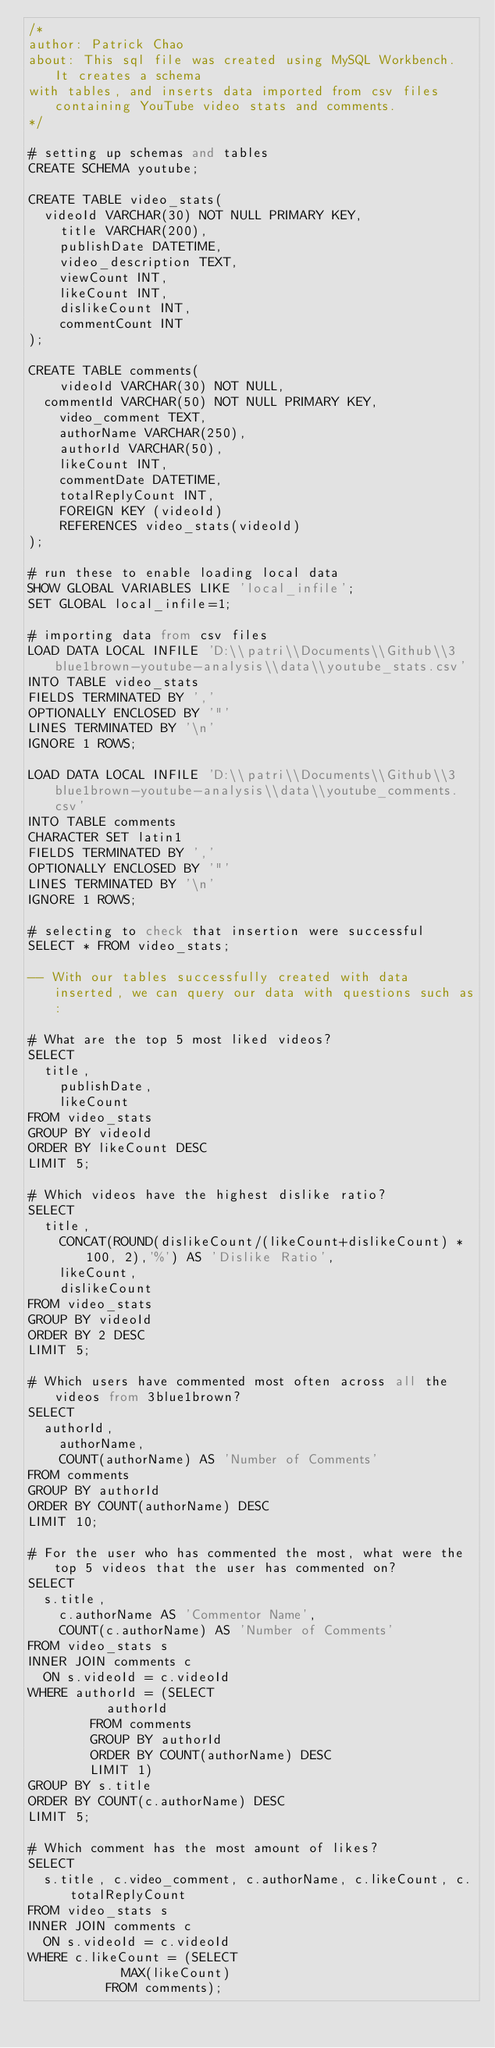Convert code to text. <code><loc_0><loc_0><loc_500><loc_500><_SQL_>/*
author: Patrick Chao
about: This sql file was created using MySQL Workbench. It creates a schema
with tables, and inserts data imported from csv files containing YouTube video stats and comments.
*/

# setting up schemas and tables
CREATE SCHEMA youtube;

CREATE TABLE video_stats(
	videoId VARCHAR(30) NOT NULL PRIMARY KEY,
    title VARCHAR(200),
    publishDate DATETIME,
    video_description TEXT,
    viewCount INT,
    likeCount INT,
    dislikeCount INT,
    commentCount INT
);
    
CREATE TABLE comments(
    videoId VARCHAR(30) NOT NULL,
	commentId VARCHAR(50) NOT NULL PRIMARY KEY,
    video_comment TEXT,
    authorName VARCHAR(250),
    authorId VARCHAR(50),
    likeCount INT,
    commentDate DATETIME,
    totalReplyCount INT,
    FOREIGN KEY (videoId)
		REFERENCES video_stats(videoId)
);
    
# run these to enable loading local data
SHOW GLOBAL VARIABLES LIKE 'local_infile';
SET GLOBAL local_infile=1;
    
# importing data from csv files
LOAD DATA LOCAL INFILE 'D:\\patri\\Documents\\Github\\3blue1brown-youtube-analysis\\data\\youtube_stats.csv'
INTO TABLE video_stats
FIELDS TERMINATED BY ','
OPTIONALLY ENCLOSED BY '"' 
LINES TERMINATED BY '\n'
IGNORE 1 ROWS;

LOAD DATA LOCAL INFILE 'D:\\patri\\Documents\\Github\\3blue1brown-youtube-analysis\\data\\youtube_comments.csv'
INTO TABLE comments
CHARACTER SET latin1
FIELDS TERMINATED BY ','
OPTIONALLY ENCLOSED BY '"' 
LINES TERMINATED BY '\n'
IGNORE 1 ROWS;

# selecting to check that insertion were successful
SELECT * FROM video_stats;

-- With our tables successfully created with data inserted, we can query our data with questions such as:

# What are the top 5 most liked videos?
SELECT
	title,
    publishDate, 
    likeCount
FROM video_stats
GROUP BY videoId
ORDER BY likeCount DESC
LIMIT 5;

# Which videos have the highest dislike ratio?
SELECT
	title, 
    CONCAT(ROUND(dislikeCount/(likeCount+dislikeCount) * 100, 2),'%') AS 'Dislike Ratio',
    likeCount, 
    dislikeCount
FROM video_stats
GROUP BY videoId
ORDER BY 2 DESC
LIMIT 5;

# Which users have commented most often across all the videos from 3blue1brown?
SELECT
	authorId, 
    authorName, 
    COUNT(authorName) AS 'Number of Comments'
FROM comments
GROUP BY authorId
ORDER BY COUNT(authorName) DESC
LIMIT 10;

# For the user who has commented the most, what were the top 5 videos that the user has commented on?
SELECT
	s.title,
    c.authorName AS 'Commentor Name', 
    COUNT(c.authorName) AS 'Number of Comments'
FROM video_stats s
INNER JOIN comments c
	ON s.videoId = c.videoId
WHERE authorId = (SELECT
					authorId
				FROM comments
				GROUP BY authorId
				ORDER BY COUNT(authorName) DESC
				LIMIT 1)
GROUP BY s.title
ORDER BY COUNT(c.authorName) DESC
LIMIT 5;

# Which comment has the most amount of likes?
SELECT
	s.title, c.video_comment, c.authorName, c.likeCount, c.totalReplyCount
FROM video_stats s
INNER JOIN comments c
	ON s.videoId = c.videoId
WHERE c.likeCount = (SELECT
						MAX(likeCount)
					FROM comments);</code> 